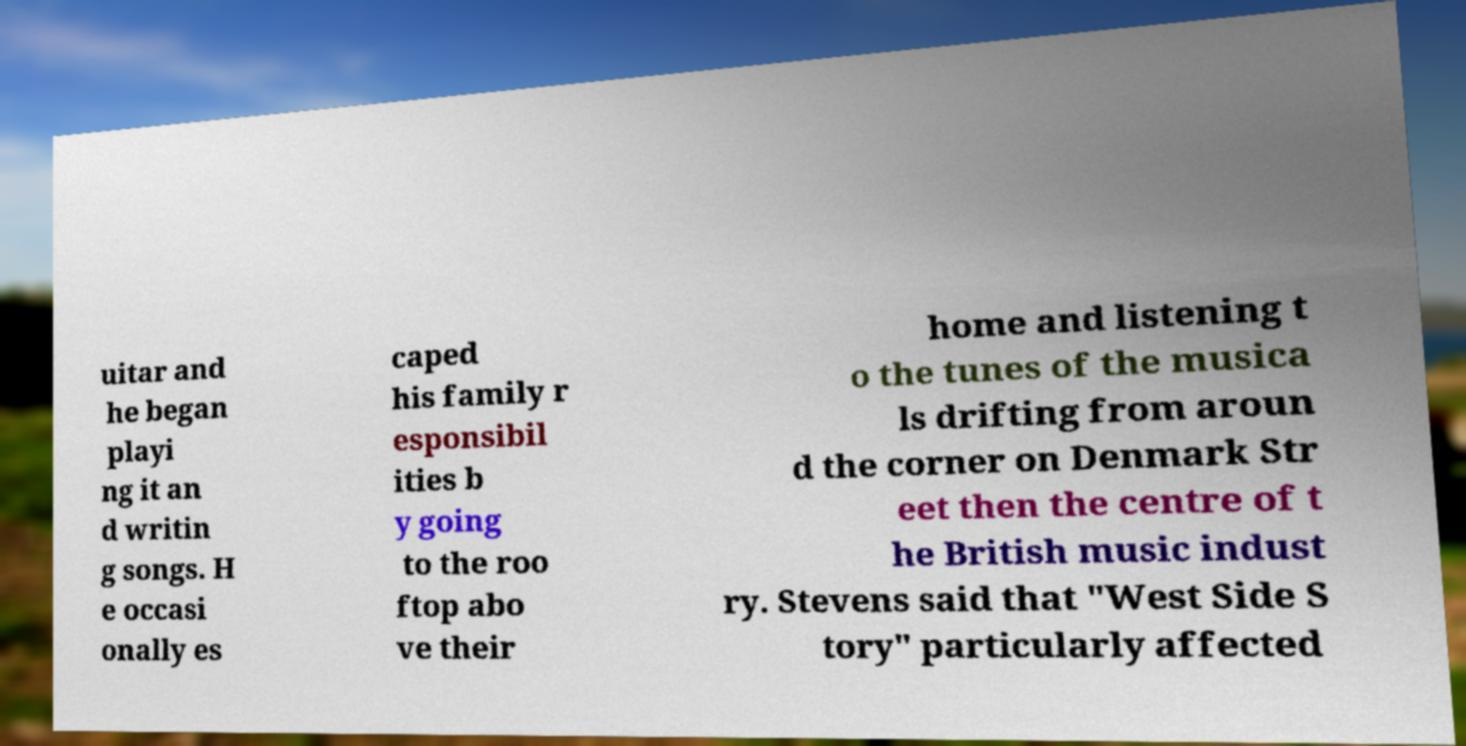I need the written content from this picture converted into text. Can you do that? uitar and he began playi ng it an d writin g songs. H e occasi onally es caped his family r esponsibil ities b y going to the roo ftop abo ve their home and listening t o the tunes of the musica ls drifting from aroun d the corner on Denmark Str eet then the centre of t he British music indust ry. Stevens said that "West Side S tory" particularly affected 